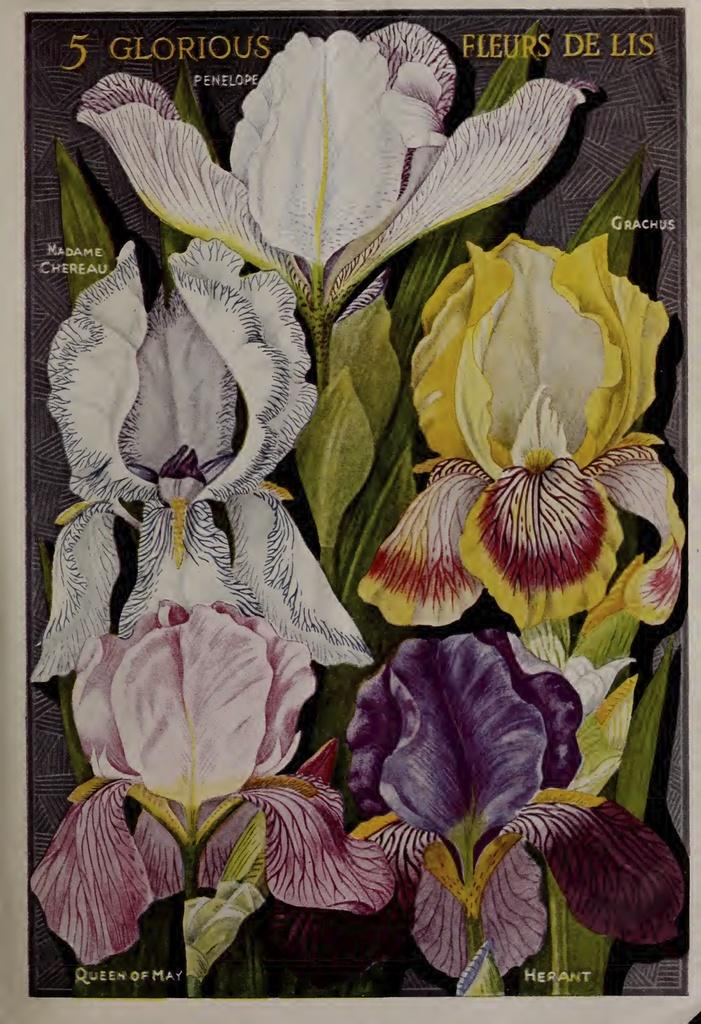What is the main subject of the image? The main subject of the image is a paper. What type of illustrations are present on the paper? There are flowers and leaves depicted on the paper. Is there any text present on the paper? Yes, there is text on the paper. Where is the cactus located in the image? There is no cactus present in the image; it only features flowers and leaves. What type of duck can be seen swimming in the image? There is no duck present in the image; it only features a paper with flowers, leaves, and text. 